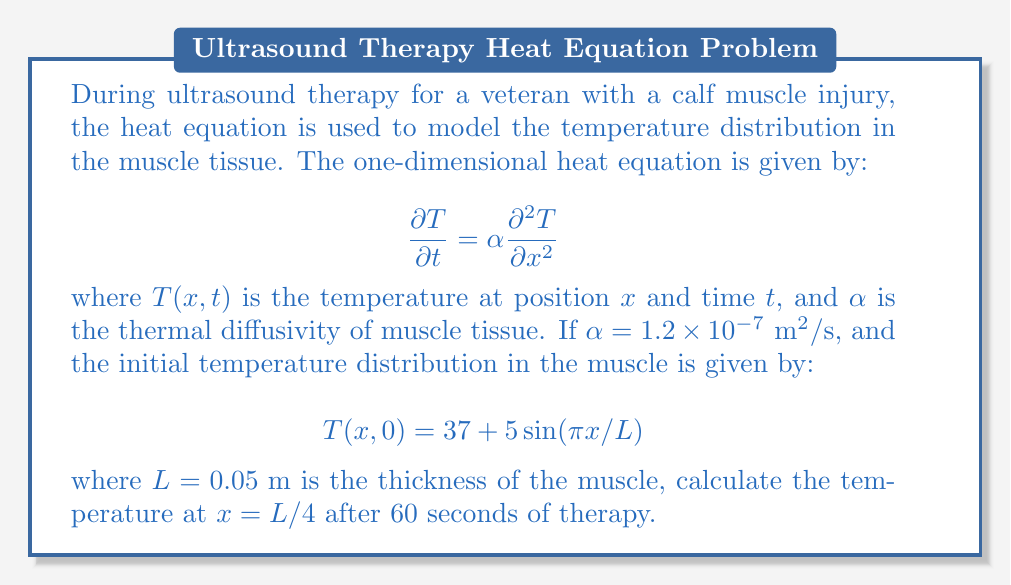Can you answer this question? To solve this problem, we'll use the separation of variables method:

1) Assume a solution of the form $T(x,t) = X(x)T(t)$.

2) Substituting into the heat equation:
   $$X(x)T'(t) = \alpha X''(x)T(t)$$
   $$\frac{T'(t)}{T(t)} = \alpha \frac{X''(x)}{X(x)} = -\lambda$$

3) This gives us two ODEs:
   $$T'(t) + \lambda \alpha T(t) = 0$$
   $$X''(x) + \lambda X(x) = 0$$

4) The general solution is:
   $$T(x,t) = \sum_{n=1}^{\infty} A_n \sin(\frac{n\pi x}{L}) e^{-\alpha (\frac{n\pi}{L})^2 t}$$

5) Given the initial condition, we can see that $n=1$ and $A_1 = 5$. Thus:
   $$T(x,t) = 37 + 5\sin(\frac{\pi x}{L}) e^{-\alpha (\frac{\pi}{L})^2 t}$$

6) Now, let's substitute the values:
   $x = L/4 = 0.0125 \text{ m}$
   $t = 60 \text{ s}$
   $\alpha = 1.2 \times 10^{-7} \text{ m}^2/\text{s}$
   $L = 0.05 \text{ m}$

7) Calculate:
   $$T(L/4,60) = 37 + 5\sin(\frac{\pi}{4}) e^{-1.2 \times 10^{-7} (\frac{\pi}{0.05})^2 60}$$
   $$= 37 + 5 \cdot 0.7071 \cdot e^{-0.2844}$$
   $$= 37 + 3.5355 \cdot 0.7524$$
   $$= 37 + 2.6602$$
   $$= 39.6602$$

Therefore, the temperature at $x = L/4$ after 60 seconds is approximately 39.66°C.
Answer: 39.66°C 